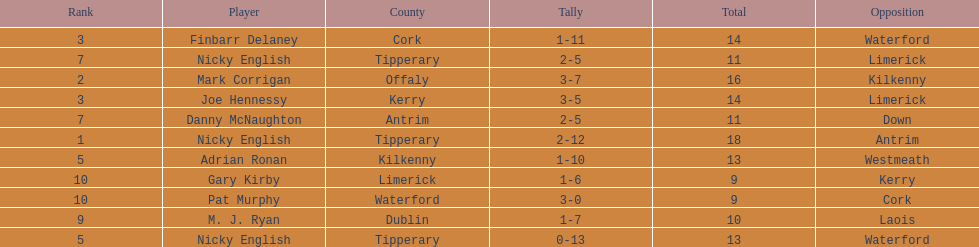If you added all the total's up, what would the number be? 138. 